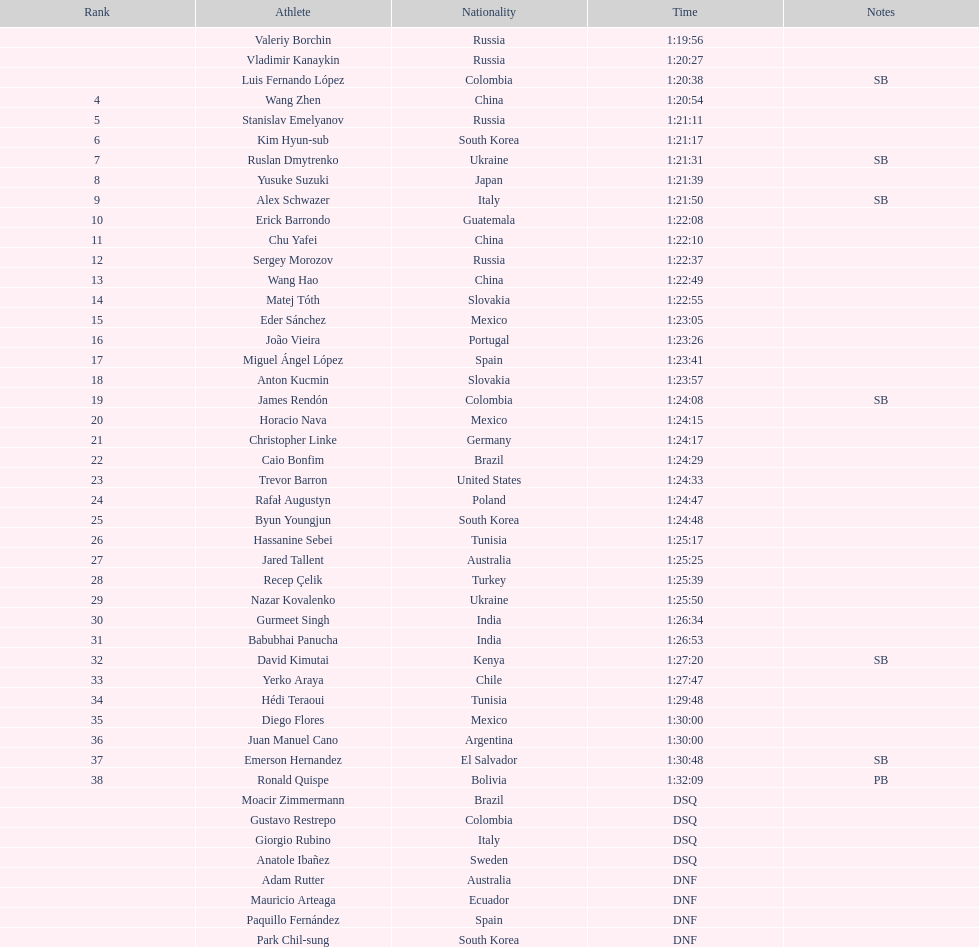Wang zhen and wang hao both originated from which nation? China. 